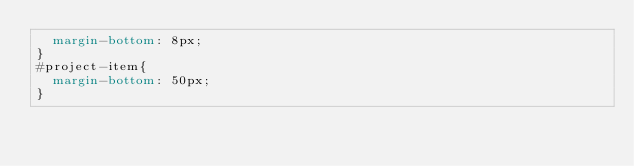<code> <loc_0><loc_0><loc_500><loc_500><_CSS_>	margin-bottom: 8px;
}
#project-item{
	margin-bottom: 50px;
}</code> 